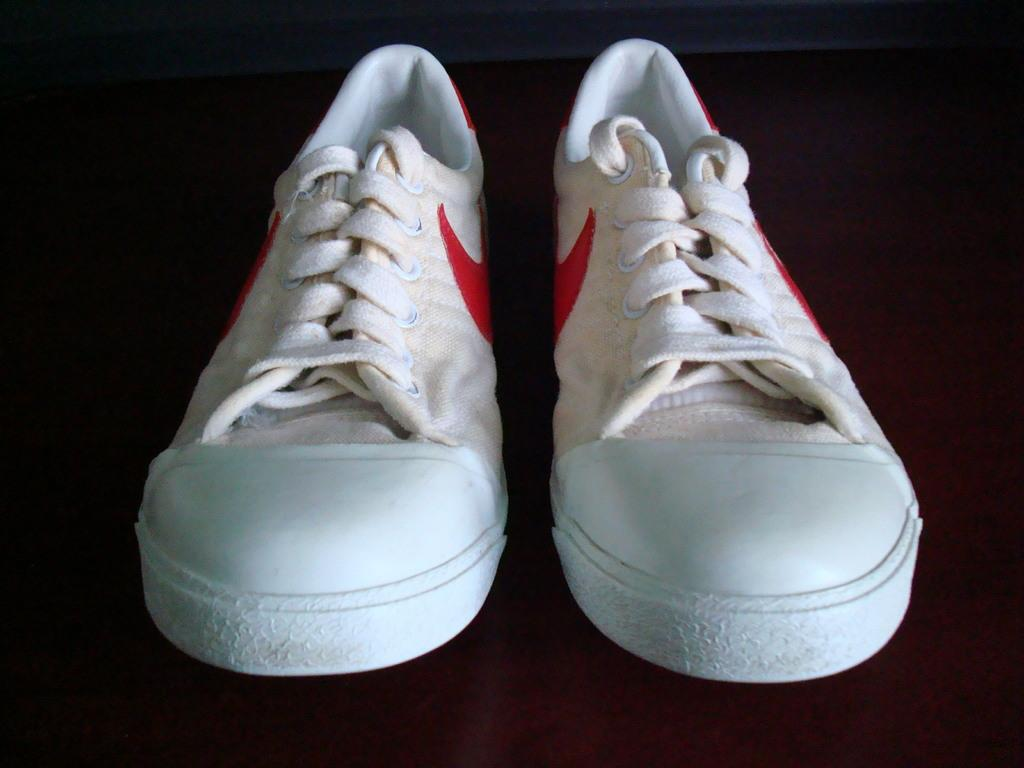What type of object is in the image? There is a pair of shoes in the image. How many rabbits are hiding in the cellar beneath the shoes in the image? There is no mention of a cellar or rabbits in the image, and therefore no such activity can be observed. 